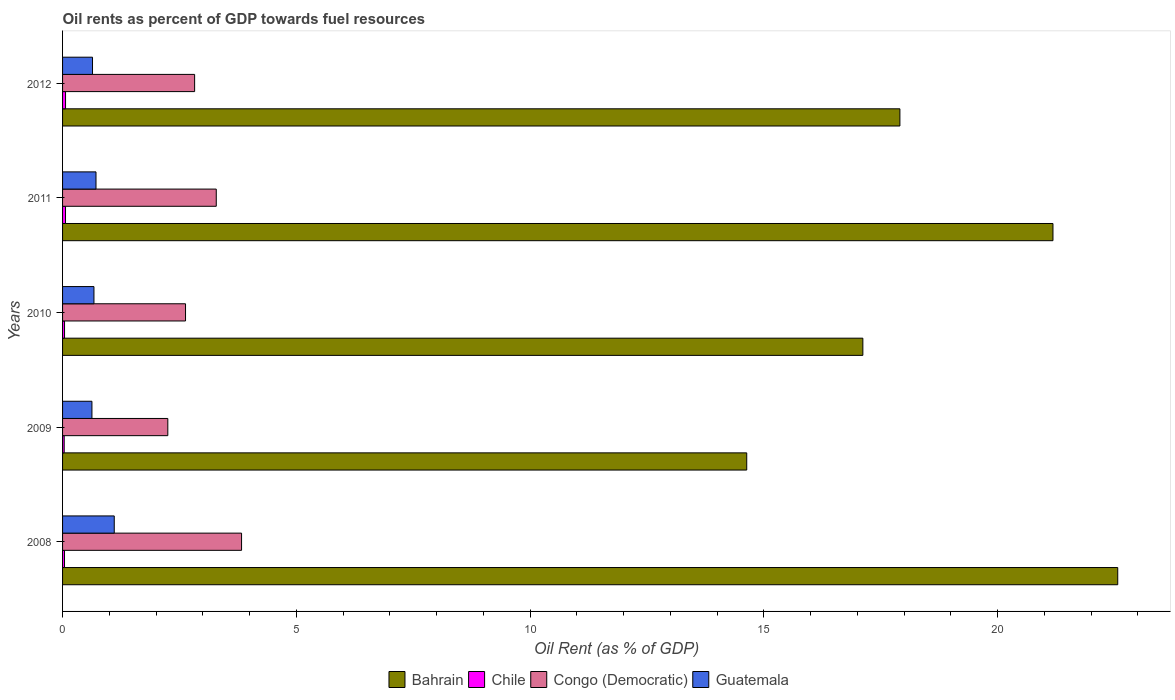How many different coloured bars are there?
Keep it short and to the point. 4. How many groups of bars are there?
Your answer should be very brief. 5. Are the number of bars per tick equal to the number of legend labels?
Make the answer very short. Yes. Are the number of bars on each tick of the Y-axis equal?
Give a very brief answer. Yes. In how many cases, is the number of bars for a given year not equal to the number of legend labels?
Provide a succinct answer. 0. What is the oil rent in Guatemala in 2010?
Offer a very short reply. 0.67. Across all years, what is the maximum oil rent in Chile?
Keep it short and to the point. 0.06. Across all years, what is the minimum oil rent in Chile?
Your answer should be very brief. 0.03. What is the total oil rent in Chile in the graph?
Give a very brief answer. 0.25. What is the difference between the oil rent in Guatemala in 2010 and that in 2011?
Your answer should be very brief. -0.04. What is the difference between the oil rent in Congo (Democratic) in 2009 and the oil rent in Guatemala in 2008?
Offer a terse response. 1.15. What is the average oil rent in Guatemala per year?
Ensure brevity in your answer.  0.75. In the year 2008, what is the difference between the oil rent in Chile and oil rent in Congo (Democratic)?
Provide a short and direct response. -3.79. What is the ratio of the oil rent in Bahrain in 2009 to that in 2010?
Offer a very short reply. 0.85. Is the oil rent in Chile in 2009 less than that in 2011?
Offer a very short reply. Yes. Is the difference between the oil rent in Chile in 2008 and 2012 greater than the difference between the oil rent in Congo (Democratic) in 2008 and 2012?
Provide a short and direct response. No. What is the difference between the highest and the second highest oil rent in Chile?
Your response must be concise. 0. What is the difference between the highest and the lowest oil rent in Chile?
Your response must be concise. 0.03. What does the 2nd bar from the top in 2008 represents?
Offer a very short reply. Congo (Democratic). Are the values on the major ticks of X-axis written in scientific E-notation?
Make the answer very short. No. Where does the legend appear in the graph?
Make the answer very short. Bottom center. How many legend labels are there?
Provide a short and direct response. 4. What is the title of the graph?
Your answer should be very brief. Oil rents as percent of GDP towards fuel resources. Does "China" appear as one of the legend labels in the graph?
Provide a succinct answer. No. What is the label or title of the X-axis?
Your answer should be compact. Oil Rent (as % of GDP). What is the Oil Rent (as % of GDP) of Bahrain in 2008?
Offer a very short reply. 22.57. What is the Oil Rent (as % of GDP) in Chile in 2008?
Your answer should be very brief. 0.04. What is the Oil Rent (as % of GDP) in Congo (Democratic) in 2008?
Give a very brief answer. 3.83. What is the Oil Rent (as % of GDP) in Guatemala in 2008?
Give a very brief answer. 1.11. What is the Oil Rent (as % of GDP) in Bahrain in 2009?
Your response must be concise. 14.63. What is the Oil Rent (as % of GDP) of Chile in 2009?
Keep it short and to the point. 0.03. What is the Oil Rent (as % of GDP) of Congo (Democratic) in 2009?
Ensure brevity in your answer.  2.25. What is the Oil Rent (as % of GDP) in Guatemala in 2009?
Offer a very short reply. 0.63. What is the Oil Rent (as % of GDP) of Bahrain in 2010?
Your response must be concise. 17.12. What is the Oil Rent (as % of GDP) in Chile in 2010?
Your answer should be very brief. 0.04. What is the Oil Rent (as % of GDP) of Congo (Democratic) in 2010?
Give a very brief answer. 2.63. What is the Oil Rent (as % of GDP) of Guatemala in 2010?
Offer a very short reply. 0.67. What is the Oil Rent (as % of GDP) in Bahrain in 2011?
Your answer should be compact. 21.18. What is the Oil Rent (as % of GDP) of Chile in 2011?
Provide a succinct answer. 0.06. What is the Oil Rent (as % of GDP) in Congo (Democratic) in 2011?
Your answer should be very brief. 3.29. What is the Oil Rent (as % of GDP) in Guatemala in 2011?
Your answer should be very brief. 0.72. What is the Oil Rent (as % of GDP) in Bahrain in 2012?
Keep it short and to the point. 17.91. What is the Oil Rent (as % of GDP) of Chile in 2012?
Provide a succinct answer. 0.06. What is the Oil Rent (as % of GDP) of Congo (Democratic) in 2012?
Offer a terse response. 2.82. What is the Oil Rent (as % of GDP) of Guatemala in 2012?
Make the answer very short. 0.64. Across all years, what is the maximum Oil Rent (as % of GDP) in Bahrain?
Keep it short and to the point. 22.57. Across all years, what is the maximum Oil Rent (as % of GDP) in Chile?
Your answer should be compact. 0.06. Across all years, what is the maximum Oil Rent (as % of GDP) in Congo (Democratic)?
Ensure brevity in your answer.  3.83. Across all years, what is the maximum Oil Rent (as % of GDP) of Guatemala?
Provide a succinct answer. 1.11. Across all years, what is the minimum Oil Rent (as % of GDP) in Bahrain?
Make the answer very short. 14.63. Across all years, what is the minimum Oil Rent (as % of GDP) in Chile?
Make the answer very short. 0.03. Across all years, what is the minimum Oil Rent (as % of GDP) in Congo (Democratic)?
Your answer should be compact. 2.25. Across all years, what is the minimum Oil Rent (as % of GDP) in Guatemala?
Make the answer very short. 0.63. What is the total Oil Rent (as % of GDP) of Bahrain in the graph?
Your answer should be compact. 93.42. What is the total Oil Rent (as % of GDP) of Chile in the graph?
Give a very brief answer. 0.25. What is the total Oil Rent (as % of GDP) in Congo (Democratic) in the graph?
Make the answer very short. 14.82. What is the total Oil Rent (as % of GDP) of Guatemala in the graph?
Make the answer very short. 3.76. What is the difference between the Oil Rent (as % of GDP) in Bahrain in 2008 and that in 2009?
Your answer should be compact. 7.94. What is the difference between the Oil Rent (as % of GDP) in Chile in 2008 and that in 2009?
Offer a very short reply. 0.01. What is the difference between the Oil Rent (as % of GDP) in Congo (Democratic) in 2008 and that in 2009?
Offer a very short reply. 1.58. What is the difference between the Oil Rent (as % of GDP) in Guatemala in 2008 and that in 2009?
Offer a terse response. 0.48. What is the difference between the Oil Rent (as % of GDP) of Bahrain in 2008 and that in 2010?
Give a very brief answer. 5.45. What is the difference between the Oil Rent (as % of GDP) of Chile in 2008 and that in 2010?
Offer a terse response. -0. What is the difference between the Oil Rent (as % of GDP) in Congo (Democratic) in 2008 and that in 2010?
Give a very brief answer. 1.2. What is the difference between the Oil Rent (as % of GDP) in Guatemala in 2008 and that in 2010?
Ensure brevity in your answer.  0.43. What is the difference between the Oil Rent (as % of GDP) in Bahrain in 2008 and that in 2011?
Your answer should be very brief. 1.39. What is the difference between the Oil Rent (as % of GDP) in Chile in 2008 and that in 2011?
Ensure brevity in your answer.  -0.02. What is the difference between the Oil Rent (as % of GDP) of Congo (Democratic) in 2008 and that in 2011?
Offer a very short reply. 0.54. What is the difference between the Oil Rent (as % of GDP) in Guatemala in 2008 and that in 2011?
Provide a short and direct response. 0.39. What is the difference between the Oil Rent (as % of GDP) in Bahrain in 2008 and that in 2012?
Provide a succinct answer. 4.66. What is the difference between the Oil Rent (as % of GDP) of Chile in 2008 and that in 2012?
Offer a terse response. -0.02. What is the difference between the Oil Rent (as % of GDP) of Congo (Democratic) in 2008 and that in 2012?
Your answer should be compact. 1. What is the difference between the Oil Rent (as % of GDP) in Guatemala in 2008 and that in 2012?
Your response must be concise. 0.46. What is the difference between the Oil Rent (as % of GDP) of Bahrain in 2009 and that in 2010?
Offer a terse response. -2.48. What is the difference between the Oil Rent (as % of GDP) of Chile in 2009 and that in 2010?
Give a very brief answer. -0.01. What is the difference between the Oil Rent (as % of GDP) of Congo (Democratic) in 2009 and that in 2010?
Offer a terse response. -0.38. What is the difference between the Oil Rent (as % of GDP) in Guatemala in 2009 and that in 2010?
Ensure brevity in your answer.  -0.04. What is the difference between the Oil Rent (as % of GDP) of Bahrain in 2009 and that in 2011?
Offer a very short reply. -6.55. What is the difference between the Oil Rent (as % of GDP) in Chile in 2009 and that in 2011?
Provide a succinct answer. -0.03. What is the difference between the Oil Rent (as % of GDP) in Congo (Democratic) in 2009 and that in 2011?
Your response must be concise. -1.04. What is the difference between the Oil Rent (as % of GDP) of Guatemala in 2009 and that in 2011?
Your response must be concise. -0.09. What is the difference between the Oil Rent (as % of GDP) of Bahrain in 2009 and that in 2012?
Offer a terse response. -3.28. What is the difference between the Oil Rent (as % of GDP) in Chile in 2009 and that in 2012?
Offer a very short reply. -0.03. What is the difference between the Oil Rent (as % of GDP) in Congo (Democratic) in 2009 and that in 2012?
Your response must be concise. -0.57. What is the difference between the Oil Rent (as % of GDP) in Guatemala in 2009 and that in 2012?
Your answer should be compact. -0.01. What is the difference between the Oil Rent (as % of GDP) of Bahrain in 2010 and that in 2011?
Your answer should be very brief. -4.07. What is the difference between the Oil Rent (as % of GDP) of Chile in 2010 and that in 2011?
Provide a succinct answer. -0.02. What is the difference between the Oil Rent (as % of GDP) in Congo (Democratic) in 2010 and that in 2011?
Offer a terse response. -0.66. What is the difference between the Oil Rent (as % of GDP) in Guatemala in 2010 and that in 2011?
Provide a short and direct response. -0.04. What is the difference between the Oil Rent (as % of GDP) in Bahrain in 2010 and that in 2012?
Offer a terse response. -0.79. What is the difference between the Oil Rent (as % of GDP) in Chile in 2010 and that in 2012?
Offer a very short reply. -0.02. What is the difference between the Oil Rent (as % of GDP) of Congo (Democratic) in 2010 and that in 2012?
Offer a terse response. -0.19. What is the difference between the Oil Rent (as % of GDP) of Guatemala in 2010 and that in 2012?
Ensure brevity in your answer.  0.03. What is the difference between the Oil Rent (as % of GDP) in Bahrain in 2011 and that in 2012?
Provide a succinct answer. 3.27. What is the difference between the Oil Rent (as % of GDP) in Chile in 2011 and that in 2012?
Make the answer very short. -0. What is the difference between the Oil Rent (as % of GDP) in Congo (Democratic) in 2011 and that in 2012?
Make the answer very short. 0.46. What is the difference between the Oil Rent (as % of GDP) of Guatemala in 2011 and that in 2012?
Your response must be concise. 0.07. What is the difference between the Oil Rent (as % of GDP) in Bahrain in 2008 and the Oil Rent (as % of GDP) in Chile in 2009?
Offer a very short reply. 22.54. What is the difference between the Oil Rent (as % of GDP) in Bahrain in 2008 and the Oil Rent (as % of GDP) in Congo (Democratic) in 2009?
Your response must be concise. 20.32. What is the difference between the Oil Rent (as % of GDP) in Bahrain in 2008 and the Oil Rent (as % of GDP) in Guatemala in 2009?
Make the answer very short. 21.94. What is the difference between the Oil Rent (as % of GDP) in Chile in 2008 and the Oil Rent (as % of GDP) in Congo (Democratic) in 2009?
Offer a very short reply. -2.21. What is the difference between the Oil Rent (as % of GDP) of Chile in 2008 and the Oil Rent (as % of GDP) of Guatemala in 2009?
Make the answer very short. -0.59. What is the difference between the Oil Rent (as % of GDP) in Congo (Democratic) in 2008 and the Oil Rent (as % of GDP) in Guatemala in 2009?
Offer a very short reply. 3.2. What is the difference between the Oil Rent (as % of GDP) of Bahrain in 2008 and the Oil Rent (as % of GDP) of Chile in 2010?
Offer a very short reply. 22.53. What is the difference between the Oil Rent (as % of GDP) of Bahrain in 2008 and the Oil Rent (as % of GDP) of Congo (Democratic) in 2010?
Provide a short and direct response. 19.94. What is the difference between the Oil Rent (as % of GDP) in Bahrain in 2008 and the Oil Rent (as % of GDP) in Guatemala in 2010?
Your answer should be very brief. 21.9. What is the difference between the Oil Rent (as % of GDP) of Chile in 2008 and the Oil Rent (as % of GDP) of Congo (Democratic) in 2010?
Your response must be concise. -2.59. What is the difference between the Oil Rent (as % of GDP) of Chile in 2008 and the Oil Rent (as % of GDP) of Guatemala in 2010?
Provide a short and direct response. -0.63. What is the difference between the Oil Rent (as % of GDP) of Congo (Democratic) in 2008 and the Oil Rent (as % of GDP) of Guatemala in 2010?
Keep it short and to the point. 3.16. What is the difference between the Oil Rent (as % of GDP) of Bahrain in 2008 and the Oil Rent (as % of GDP) of Chile in 2011?
Your response must be concise. 22.51. What is the difference between the Oil Rent (as % of GDP) in Bahrain in 2008 and the Oil Rent (as % of GDP) in Congo (Democratic) in 2011?
Your answer should be compact. 19.28. What is the difference between the Oil Rent (as % of GDP) in Bahrain in 2008 and the Oil Rent (as % of GDP) in Guatemala in 2011?
Offer a terse response. 21.86. What is the difference between the Oil Rent (as % of GDP) of Chile in 2008 and the Oil Rent (as % of GDP) of Congo (Democratic) in 2011?
Your answer should be very brief. -3.25. What is the difference between the Oil Rent (as % of GDP) of Chile in 2008 and the Oil Rent (as % of GDP) of Guatemala in 2011?
Give a very brief answer. -0.67. What is the difference between the Oil Rent (as % of GDP) in Congo (Democratic) in 2008 and the Oil Rent (as % of GDP) in Guatemala in 2011?
Ensure brevity in your answer.  3.11. What is the difference between the Oil Rent (as % of GDP) in Bahrain in 2008 and the Oil Rent (as % of GDP) in Chile in 2012?
Ensure brevity in your answer.  22.51. What is the difference between the Oil Rent (as % of GDP) in Bahrain in 2008 and the Oil Rent (as % of GDP) in Congo (Democratic) in 2012?
Keep it short and to the point. 19.75. What is the difference between the Oil Rent (as % of GDP) of Bahrain in 2008 and the Oil Rent (as % of GDP) of Guatemala in 2012?
Offer a very short reply. 21.93. What is the difference between the Oil Rent (as % of GDP) of Chile in 2008 and the Oil Rent (as % of GDP) of Congo (Democratic) in 2012?
Give a very brief answer. -2.78. What is the difference between the Oil Rent (as % of GDP) in Chile in 2008 and the Oil Rent (as % of GDP) in Guatemala in 2012?
Your answer should be very brief. -0.6. What is the difference between the Oil Rent (as % of GDP) in Congo (Democratic) in 2008 and the Oil Rent (as % of GDP) in Guatemala in 2012?
Offer a very short reply. 3.19. What is the difference between the Oil Rent (as % of GDP) in Bahrain in 2009 and the Oil Rent (as % of GDP) in Chile in 2010?
Make the answer very short. 14.59. What is the difference between the Oil Rent (as % of GDP) of Bahrain in 2009 and the Oil Rent (as % of GDP) of Congo (Democratic) in 2010?
Keep it short and to the point. 12. What is the difference between the Oil Rent (as % of GDP) in Bahrain in 2009 and the Oil Rent (as % of GDP) in Guatemala in 2010?
Offer a very short reply. 13.96. What is the difference between the Oil Rent (as % of GDP) in Chile in 2009 and the Oil Rent (as % of GDP) in Congo (Democratic) in 2010?
Offer a terse response. -2.6. What is the difference between the Oil Rent (as % of GDP) in Chile in 2009 and the Oil Rent (as % of GDP) in Guatemala in 2010?
Your answer should be compact. -0.64. What is the difference between the Oil Rent (as % of GDP) of Congo (Democratic) in 2009 and the Oil Rent (as % of GDP) of Guatemala in 2010?
Ensure brevity in your answer.  1.58. What is the difference between the Oil Rent (as % of GDP) of Bahrain in 2009 and the Oil Rent (as % of GDP) of Chile in 2011?
Offer a terse response. 14.57. What is the difference between the Oil Rent (as % of GDP) in Bahrain in 2009 and the Oil Rent (as % of GDP) in Congo (Democratic) in 2011?
Offer a very short reply. 11.35. What is the difference between the Oil Rent (as % of GDP) of Bahrain in 2009 and the Oil Rent (as % of GDP) of Guatemala in 2011?
Your response must be concise. 13.92. What is the difference between the Oil Rent (as % of GDP) of Chile in 2009 and the Oil Rent (as % of GDP) of Congo (Democratic) in 2011?
Offer a very short reply. -3.25. What is the difference between the Oil Rent (as % of GDP) of Chile in 2009 and the Oil Rent (as % of GDP) of Guatemala in 2011?
Provide a short and direct response. -0.68. What is the difference between the Oil Rent (as % of GDP) in Congo (Democratic) in 2009 and the Oil Rent (as % of GDP) in Guatemala in 2011?
Keep it short and to the point. 1.54. What is the difference between the Oil Rent (as % of GDP) in Bahrain in 2009 and the Oil Rent (as % of GDP) in Chile in 2012?
Provide a short and direct response. 14.57. What is the difference between the Oil Rent (as % of GDP) in Bahrain in 2009 and the Oil Rent (as % of GDP) in Congo (Democratic) in 2012?
Make the answer very short. 11.81. What is the difference between the Oil Rent (as % of GDP) in Bahrain in 2009 and the Oil Rent (as % of GDP) in Guatemala in 2012?
Provide a succinct answer. 13.99. What is the difference between the Oil Rent (as % of GDP) in Chile in 2009 and the Oil Rent (as % of GDP) in Congo (Democratic) in 2012?
Provide a succinct answer. -2.79. What is the difference between the Oil Rent (as % of GDP) of Chile in 2009 and the Oil Rent (as % of GDP) of Guatemala in 2012?
Offer a very short reply. -0.61. What is the difference between the Oil Rent (as % of GDP) in Congo (Democratic) in 2009 and the Oil Rent (as % of GDP) in Guatemala in 2012?
Provide a succinct answer. 1.61. What is the difference between the Oil Rent (as % of GDP) in Bahrain in 2010 and the Oil Rent (as % of GDP) in Chile in 2011?
Keep it short and to the point. 17.05. What is the difference between the Oil Rent (as % of GDP) of Bahrain in 2010 and the Oil Rent (as % of GDP) of Congo (Democratic) in 2011?
Offer a terse response. 13.83. What is the difference between the Oil Rent (as % of GDP) in Bahrain in 2010 and the Oil Rent (as % of GDP) in Guatemala in 2011?
Your answer should be very brief. 16.4. What is the difference between the Oil Rent (as % of GDP) in Chile in 2010 and the Oil Rent (as % of GDP) in Congo (Democratic) in 2011?
Offer a terse response. -3.25. What is the difference between the Oil Rent (as % of GDP) of Chile in 2010 and the Oil Rent (as % of GDP) of Guatemala in 2011?
Ensure brevity in your answer.  -0.67. What is the difference between the Oil Rent (as % of GDP) in Congo (Democratic) in 2010 and the Oil Rent (as % of GDP) in Guatemala in 2011?
Your response must be concise. 1.92. What is the difference between the Oil Rent (as % of GDP) of Bahrain in 2010 and the Oil Rent (as % of GDP) of Chile in 2012?
Offer a terse response. 17.05. What is the difference between the Oil Rent (as % of GDP) in Bahrain in 2010 and the Oil Rent (as % of GDP) in Congo (Democratic) in 2012?
Your answer should be very brief. 14.29. What is the difference between the Oil Rent (as % of GDP) in Bahrain in 2010 and the Oil Rent (as % of GDP) in Guatemala in 2012?
Ensure brevity in your answer.  16.48. What is the difference between the Oil Rent (as % of GDP) of Chile in 2010 and the Oil Rent (as % of GDP) of Congo (Democratic) in 2012?
Give a very brief answer. -2.78. What is the difference between the Oil Rent (as % of GDP) of Chile in 2010 and the Oil Rent (as % of GDP) of Guatemala in 2012?
Offer a terse response. -0.6. What is the difference between the Oil Rent (as % of GDP) of Congo (Democratic) in 2010 and the Oil Rent (as % of GDP) of Guatemala in 2012?
Your answer should be very brief. 1.99. What is the difference between the Oil Rent (as % of GDP) of Bahrain in 2011 and the Oil Rent (as % of GDP) of Chile in 2012?
Your answer should be compact. 21.12. What is the difference between the Oil Rent (as % of GDP) in Bahrain in 2011 and the Oil Rent (as % of GDP) in Congo (Democratic) in 2012?
Ensure brevity in your answer.  18.36. What is the difference between the Oil Rent (as % of GDP) of Bahrain in 2011 and the Oil Rent (as % of GDP) of Guatemala in 2012?
Provide a short and direct response. 20.54. What is the difference between the Oil Rent (as % of GDP) in Chile in 2011 and the Oil Rent (as % of GDP) in Congo (Democratic) in 2012?
Offer a terse response. -2.76. What is the difference between the Oil Rent (as % of GDP) in Chile in 2011 and the Oil Rent (as % of GDP) in Guatemala in 2012?
Ensure brevity in your answer.  -0.58. What is the difference between the Oil Rent (as % of GDP) in Congo (Democratic) in 2011 and the Oil Rent (as % of GDP) in Guatemala in 2012?
Your response must be concise. 2.65. What is the average Oil Rent (as % of GDP) of Bahrain per year?
Keep it short and to the point. 18.68. What is the average Oil Rent (as % of GDP) of Chile per year?
Make the answer very short. 0.05. What is the average Oil Rent (as % of GDP) in Congo (Democratic) per year?
Make the answer very short. 2.96. What is the average Oil Rent (as % of GDP) in Guatemala per year?
Your answer should be compact. 0.75. In the year 2008, what is the difference between the Oil Rent (as % of GDP) of Bahrain and Oil Rent (as % of GDP) of Chile?
Offer a very short reply. 22.53. In the year 2008, what is the difference between the Oil Rent (as % of GDP) of Bahrain and Oil Rent (as % of GDP) of Congo (Democratic)?
Your answer should be very brief. 18.74. In the year 2008, what is the difference between the Oil Rent (as % of GDP) in Bahrain and Oil Rent (as % of GDP) in Guatemala?
Give a very brief answer. 21.46. In the year 2008, what is the difference between the Oil Rent (as % of GDP) of Chile and Oil Rent (as % of GDP) of Congo (Democratic)?
Your answer should be compact. -3.79. In the year 2008, what is the difference between the Oil Rent (as % of GDP) of Chile and Oil Rent (as % of GDP) of Guatemala?
Provide a short and direct response. -1.06. In the year 2008, what is the difference between the Oil Rent (as % of GDP) of Congo (Democratic) and Oil Rent (as % of GDP) of Guatemala?
Give a very brief answer. 2.72. In the year 2009, what is the difference between the Oil Rent (as % of GDP) of Bahrain and Oil Rent (as % of GDP) of Chile?
Keep it short and to the point. 14.6. In the year 2009, what is the difference between the Oil Rent (as % of GDP) in Bahrain and Oil Rent (as % of GDP) in Congo (Democratic)?
Your response must be concise. 12.38. In the year 2009, what is the difference between the Oil Rent (as % of GDP) in Bahrain and Oil Rent (as % of GDP) in Guatemala?
Make the answer very short. 14.01. In the year 2009, what is the difference between the Oil Rent (as % of GDP) of Chile and Oil Rent (as % of GDP) of Congo (Democratic)?
Your answer should be compact. -2.22. In the year 2009, what is the difference between the Oil Rent (as % of GDP) in Chile and Oil Rent (as % of GDP) in Guatemala?
Offer a very short reply. -0.59. In the year 2009, what is the difference between the Oil Rent (as % of GDP) in Congo (Democratic) and Oil Rent (as % of GDP) in Guatemala?
Provide a succinct answer. 1.62. In the year 2010, what is the difference between the Oil Rent (as % of GDP) of Bahrain and Oil Rent (as % of GDP) of Chile?
Offer a terse response. 17.08. In the year 2010, what is the difference between the Oil Rent (as % of GDP) in Bahrain and Oil Rent (as % of GDP) in Congo (Democratic)?
Offer a terse response. 14.49. In the year 2010, what is the difference between the Oil Rent (as % of GDP) of Bahrain and Oil Rent (as % of GDP) of Guatemala?
Offer a terse response. 16.45. In the year 2010, what is the difference between the Oil Rent (as % of GDP) of Chile and Oil Rent (as % of GDP) of Congo (Democratic)?
Ensure brevity in your answer.  -2.59. In the year 2010, what is the difference between the Oil Rent (as % of GDP) in Chile and Oil Rent (as % of GDP) in Guatemala?
Ensure brevity in your answer.  -0.63. In the year 2010, what is the difference between the Oil Rent (as % of GDP) of Congo (Democratic) and Oil Rent (as % of GDP) of Guatemala?
Your answer should be compact. 1.96. In the year 2011, what is the difference between the Oil Rent (as % of GDP) in Bahrain and Oil Rent (as % of GDP) in Chile?
Provide a succinct answer. 21.12. In the year 2011, what is the difference between the Oil Rent (as % of GDP) of Bahrain and Oil Rent (as % of GDP) of Congo (Democratic)?
Offer a terse response. 17.9. In the year 2011, what is the difference between the Oil Rent (as % of GDP) in Bahrain and Oil Rent (as % of GDP) in Guatemala?
Your answer should be very brief. 20.47. In the year 2011, what is the difference between the Oil Rent (as % of GDP) of Chile and Oil Rent (as % of GDP) of Congo (Democratic)?
Your answer should be compact. -3.22. In the year 2011, what is the difference between the Oil Rent (as % of GDP) in Chile and Oil Rent (as % of GDP) in Guatemala?
Your answer should be compact. -0.65. In the year 2011, what is the difference between the Oil Rent (as % of GDP) of Congo (Democratic) and Oil Rent (as % of GDP) of Guatemala?
Ensure brevity in your answer.  2.57. In the year 2012, what is the difference between the Oil Rent (as % of GDP) in Bahrain and Oil Rent (as % of GDP) in Chile?
Keep it short and to the point. 17.85. In the year 2012, what is the difference between the Oil Rent (as % of GDP) in Bahrain and Oil Rent (as % of GDP) in Congo (Democratic)?
Provide a succinct answer. 15.09. In the year 2012, what is the difference between the Oil Rent (as % of GDP) of Bahrain and Oil Rent (as % of GDP) of Guatemala?
Provide a short and direct response. 17.27. In the year 2012, what is the difference between the Oil Rent (as % of GDP) in Chile and Oil Rent (as % of GDP) in Congo (Democratic)?
Provide a short and direct response. -2.76. In the year 2012, what is the difference between the Oil Rent (as % of GDP) in Chile and Oil Rent (as % of GDP) in Guatemala?
Your answer should be very brief. -0.58. In the year 2012, what is the difference between the Oil Rent (as % of GDP) in Congo (Democratic) and Oil Rent (as % of GDP) in Guatemala?
Ensure brevity in your answer.  2.18. What is the ratio of the Oil Rent (as % of GDP) of Bahrain in 2008 to that in 2009?
Give a very brief answer. 1.54. What is the ratio of the Oil Rent (as % of GDP) in Chile in 2008 to that in 2009?
Your response must be concise. 1.2. What is the ratio of the Oil Rent (as % of GDP) of Congo (Democratic) in 2008 to that in 2009?
Offer a very short reply. 1.7. What is the ratio of the Oil Rent (as % of GDP) in Guatemala in 2008 to that in 2009?
Your answer should be very brief. 1.76. What is the ratio of the Oil Rent (as % of GDP) of Bahrain in 2008 to that in 2010?
Your answer should be compact. 1.32. What is the ratio of the Oil Rent (as % of GDP) of Chile in 2008 to that in 2010?
Provide a short and direct response. 0.99. What is the ratio of the Oil Rent (as % of GDP) in Congo (Democratic) in 2008 to that in 2010?
Keep it short and to the point. 1.46. What is the ratio of the Oil Rent (as % of GDP) of Guatemala in 2008 to that in 2010?
Provide a succinct answer. 1.65. What is the ratio of the Oil Rent (as % of GDP) in Bahrain in 2008 to that in 2011?
Your response must be concise. 1.07. What is the ratio of the Oil Rent (as % of GDP) in Chile in 2008 to that in 2011?
Offer a terse response. 0.66. What is the ratio of the Oil Rent (as % of GDP) in Congo (Democratic) in 2008 to that in 2011?
Offer a terse response. 1.16. What is the ratio of the Oil Rent (as % of GDP) of Guatemala in 2008 to that in 2011?
Offer a terse response. 1.55. What is the ratio of the Oil Rent (as % of GDP) in Bahrain in 2008 to that in 2012?
Give a very brief answer. 1.26. What is the ratio of the Oil Rent (as % of GDP) of Chile in 2008 to that in 2012?
Offer a terse response. 0.66. What is the ratio of the Oil Rent (as % of GDP) of Congo (Democratic) in 2008 to that in 2012?
Your answer should be compact. 1.36. What is the ratio of the Oil Rent (as % of GDP) of Guatemala in 2008 to that in 2012?
Offer a very short reply. 1.73. What is the ratio of the Oil Rent (as % of GDP) of Bahrain in 2009 to that in 2010?
Offer a terse response. 0.85. What is the ratio of the Oil Rent (as % of GDP) in Chile in 2009 to that in 2010?
Ensure brevity in your answer.  0.82. What is the ratio of the Oil Rent (as % of GDP) of Congo (Democratic) in 2009 to that in 2010?
Ensure brevity in your answer.  0.86. What is the ratio of the Oil Rent (as % of GDP) of Guatemala in 2009 to that in 2010?
Your answer should be compact. 0.94. What is the ratio of the Oil Rent (as % of GDP) of Bahrain in 2009 to that in 2011?
Your answer should be compact. 0.69. What is the ratio of the Oil Rent (as % of GDP) of Chile in 2009 to that in 2011?
Ensure brevity in your answer.  0.55. What is the ratio of the Oil Rent (as % of GDP) in Congo (Democratic) in 2009 to that in 2011?
Offer a terse response. 0.68. What is the ratio of the Oil Rent (as % of GDP) of Guatemala in 2009 to that in 2011?
Make the answer very short. 0.88. What is the ratio of the Oil Rent (as % of GDP) of Bahrain in 2009 to that in 2012?
Ensure brevity in your answer.  0.82. What is the ratio of the Oil Rent (as % of GDP) in Chile in 2009 to that in 2012?
Make the answer very short. 0.55. What is the ratio of the Oil Rent (as % of GDP) in Congo (Democratic) in 2009 to that in 2012?
Offer a terse response. 0.8. What is the ratio of the Oil Rent (as % of GDP) of Guatemala in 2009 to that in 2012?
Ensure brevity in your answer.  0.98. What is the ratio of the Oil Rent (as % of GDP) in Bahrain in 2010 to that in 2011?
Give a very brief answer. 0.81. What is the ratio of the Oil Rent (as % of GDP) in Chile in 2010 to that in 2011?
Your response must be concise. 0.67. What is the ratio of the Oil Rent (as % of GDP) in Congo (Democratic) in 2010 to that in 2011?
Your answer should be very brief. 0.8. What is the ratio of the Oil Rent (as % of GDP) in Guatemala in 2010 to that in 2011?
Your response must be concise. 0.94. What is the ratio of the Oil Rent (as % of GDP) in Bahrain in 2010 to that in 2012?
Keep it short and to the point. 0.96. What is the ratio of the Oil Rent (as % of GDP) of Chile in 2010 to that in 2012?
Give a very brief answer. 0.67. What is the ratio of the Oil Rent (as % of GDP) in Congo (Democratic) in 2010 to that in 2012?
Ensure brevity in your answer.  0.93. What is the ratio of the Oil Rent (as % of GDP) of Guatemala in 2010 to that in 2012?
Your answer should be very brief. 1.05. What is the ratio of the Oil Rent (as % of GDP) in Bahrain in 2011 to that in 2012?
Your response must be concise. 1.18. What is the ratio of the Oil Rent (as % of GDP) in Congo (Democratic) in 2011 to that in 2012?
Keep it short and to the point. 1.16. What is the ratio of the Oil Rent (as % of GDP) of Guatemala in 2011 to that in 2012?
Your answer should be compact. 1.12. What is the difference between the highest and the second highest Oil Rent (as % of GDP) in Bahrain?
Give a very brief answer. 1.39. What is the difference between the highest and the second highest Oil Rent (as % of GDP) in Congo (Democratic)?
Ensure brevity in your answer.  0.54. What is the difference between the highest and the second highest Oil Rent (as % of GDP) of Guatemala?
Your response must be concise. 0.39. What is the difference between the highest and the lowest Oil Rent (as % of GDP) in Bahrain?
Provide a succinct answer. 7.94. What is the difference between the highest and the lowest Oil Rent (as % of GDP) in Chile?
Ensure brevity in your answer.  0.03. What is the difference between the highest and the lowest Oil Rent (as % of GDP) in Congo (Democratic)?
Ensure brevity in your answer.  1.58. What is the difference between the highest and the lowest Oil Rent (as % of GDP) of Guatemala?
Offer a very short reply. 0.48. 